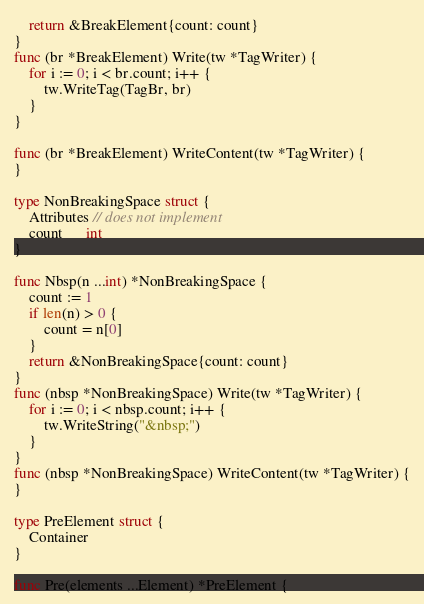Convert code to text. <code><loc_0><loc_0><loc_500><loc_500><_Go_>	return &BreakElement{count: count}
}
func (br *BreakElement) Write(tw *TagWriter) {
	for i := 0; i < br.count; i++ {
		tw.WriteTag(TagBr, br)
	}
}

func (br *BreakElement) WriteContent(tw *TagWriter) {
}

type NonBreakingSpace struct {
	Attributes // does not implement
	count      int
}

func Nbsp(n ...int) *NonBreakingSpace {
	count := 1
	if len(n) > 0 {
		count = n[0]
	}
	return &NonBreakingSpace{count: count}
}
func (nbsp *NonBreakingSpace) Write(tw *TagWriter) {
	for i := 0; i < nbsp.count; i++ {
		tw.WriteString("&nbsp;")
	}
}
func (nbsp *NonBreakingSpace) WriteContent(tw *TagWriter) {
}

type PreElement struct {
	Container
}

func Pre(elements ...Element) *PreElement {</code> 